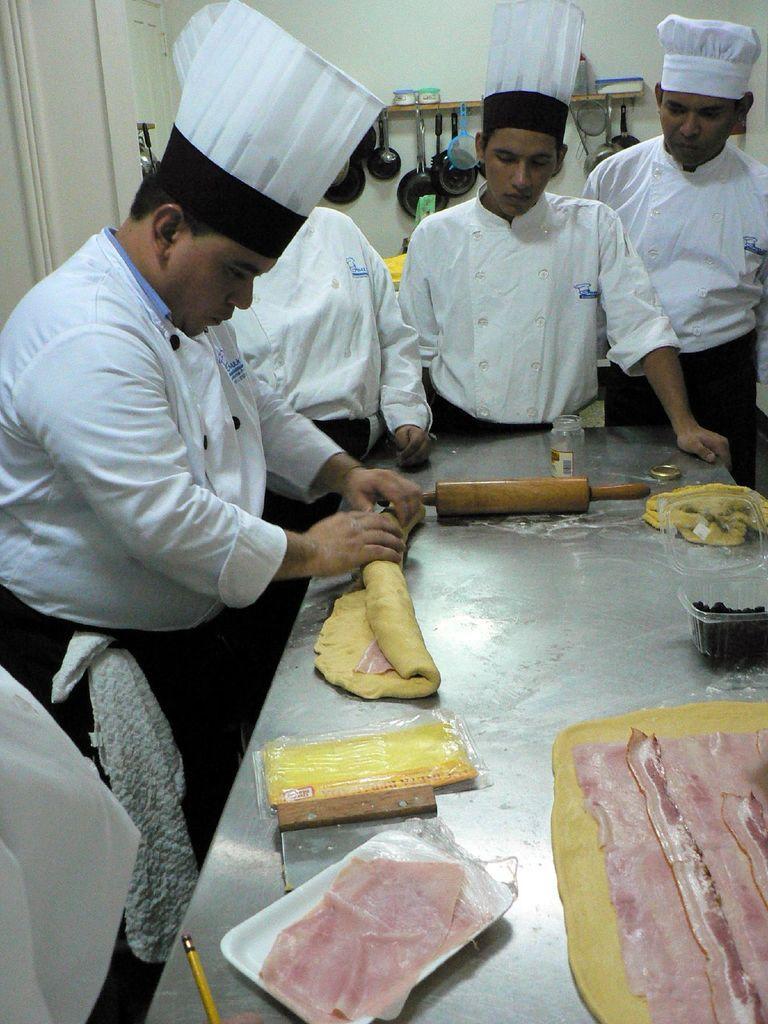How would you summarize this image in a sentence or two? In the center of the picture there is a table, on the table there are food items like meat, batter and some other kitchen utensils, around the table there are people in the dresses of chef standing. In the background there are pans, spatulas and other kitchen utensils and there is wall painted white. 